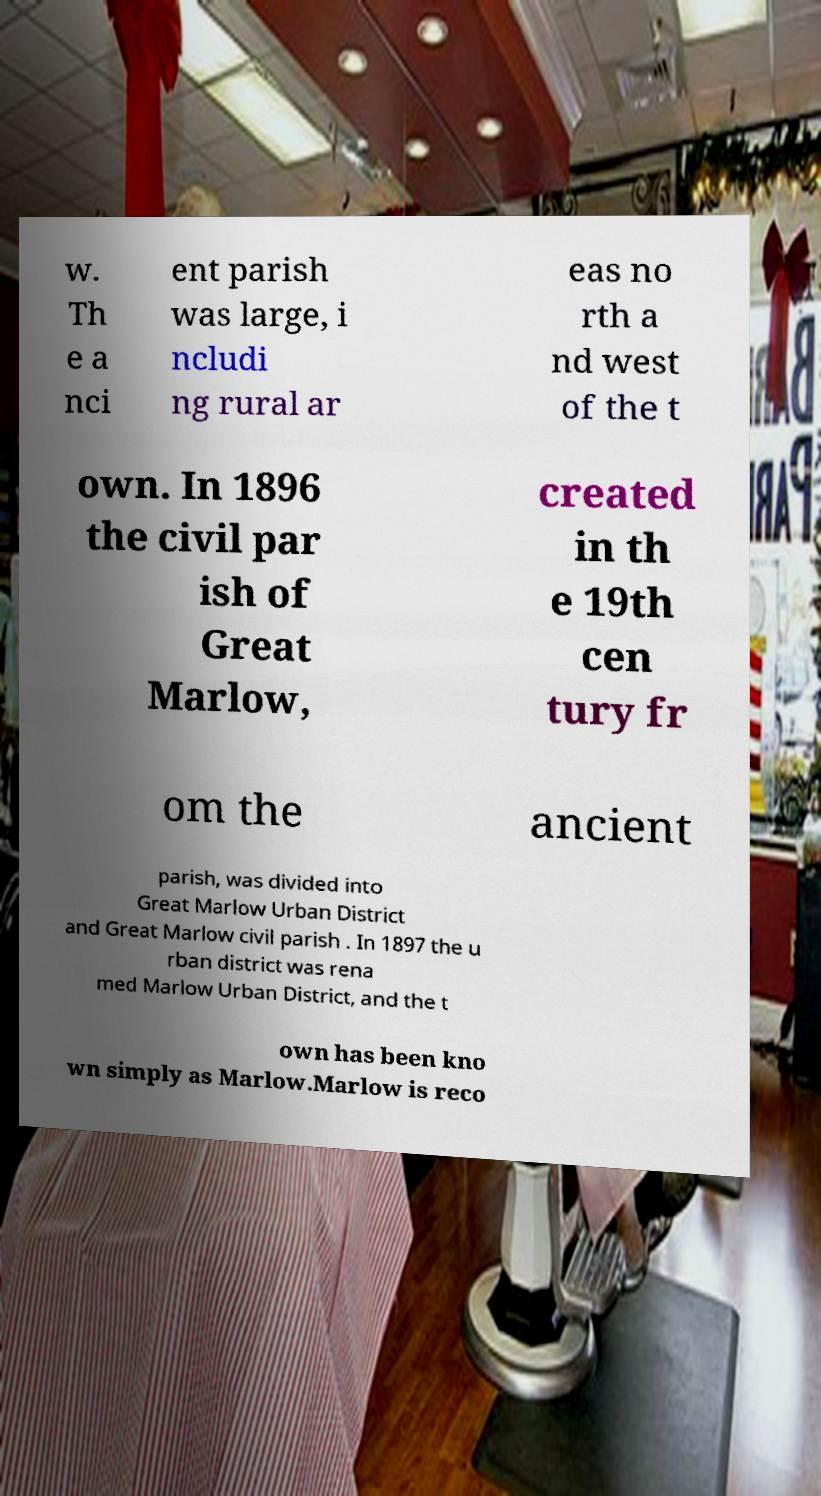Can you accurately transcribe the text from the provided image for me? w. Th e a nci ent parish was large, i ncludi ng rural ar eas no rth a nd west of the t own. In 1896 the civil par ish of Great Marlow, created in th e 19th cen tury fr om the ancient parish, was divided into Great Marlow Urban District and Great Marlow civil parish . In 1897 the u rban district was rena med Marlow Urban District, and the t own has been kno wn simply as Marlow.Marlow is reco 